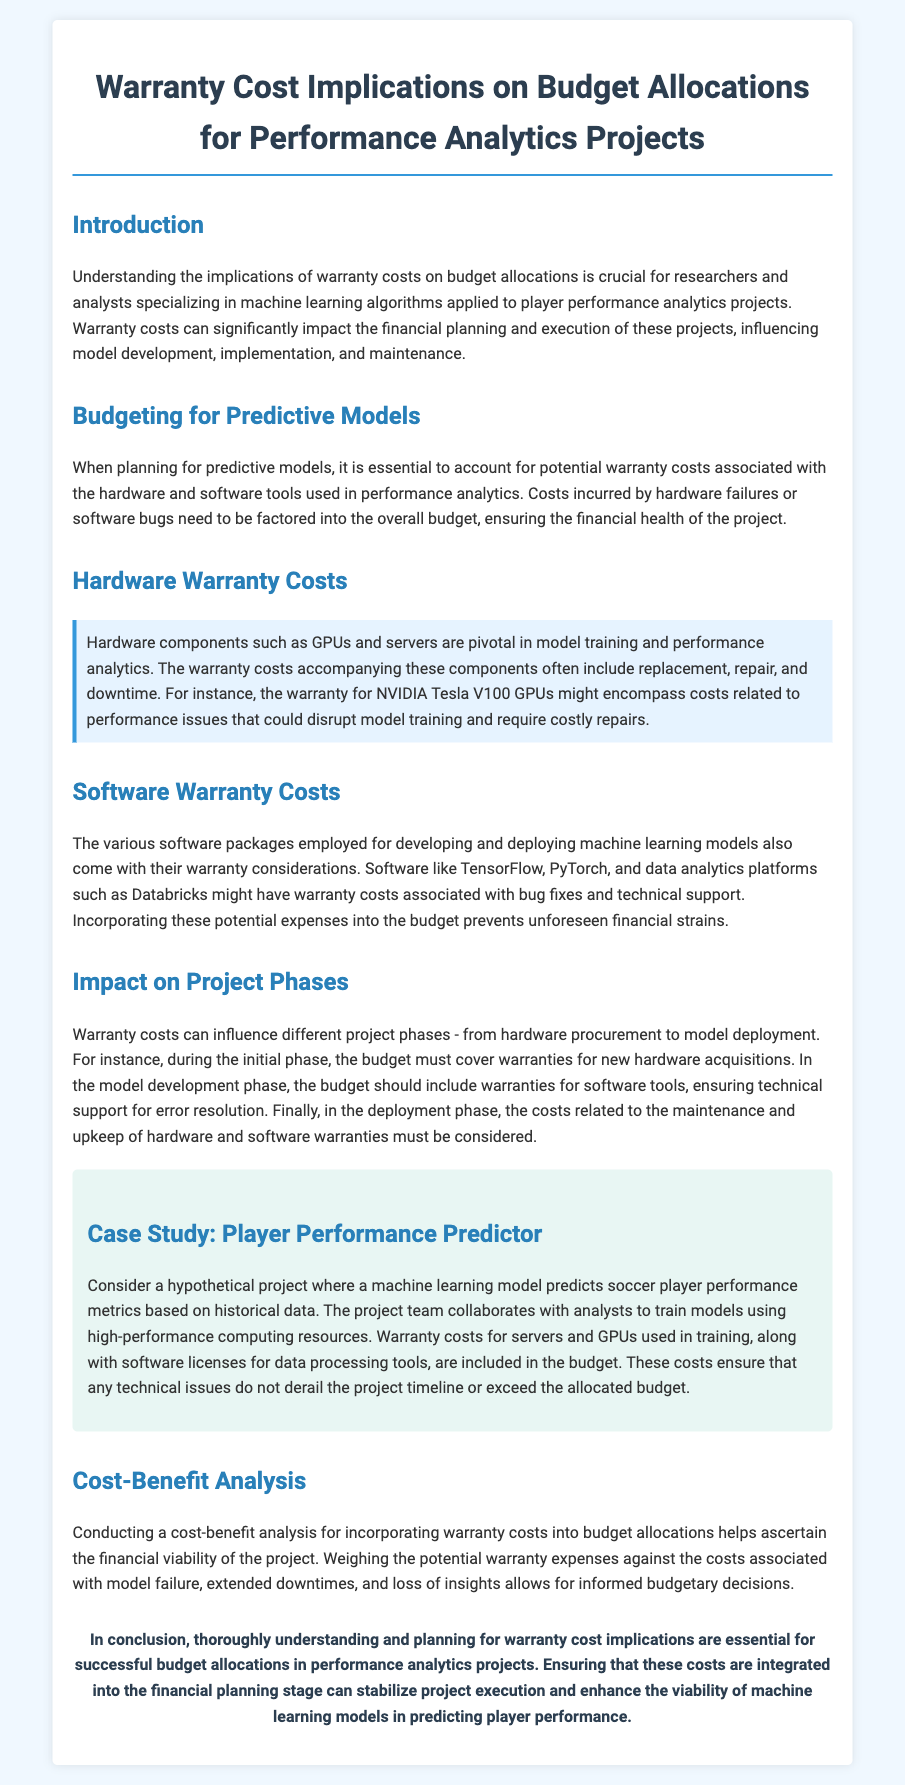What is the main focus of the document? The document focuses on the implications of warranty costs on budget allocations for performance analytics projects.
Answer: warranty costs on budget allocations What types of hardware are mentioned in the document? The document mentions GPUs and servers as hardware pivotal in model training.
Answer: GPUs and servers Which software tools are referred to regarding warranty costs? The document references TensorFlow and PyTorch as software with warranty considerations.
Answer: TensorFlow and PyTorch What phase must include warranty coverage for new hardware acquisitions? The initial phase of the project must cover warranties for new hardware.
Answer: initial phase What is the purpose of conducting a cost-benefit analysis? A cost-benefit analysis helps ascertain the financial viability of incorporating warranty costs.
Answer: financial viability What does the case study focus on? The case study focuses on a machine learning model predicting soccer player performance metrics.
Answer: predicting soccer player performance metrics How do warranty costs affect the model development phase? Warranty costs need to be included for software tools to ensure technical support.
Answer: technical support What financial strategy is emphasized for successful project execution? The document emphasizes integrating warranty costs into financial planning.
Answer: integrating warranty costs into financial planning 